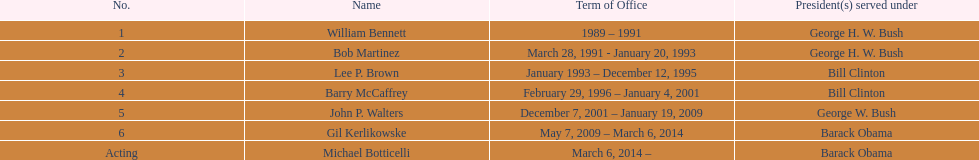When did john p. walters end his term? January 19, 2009. 